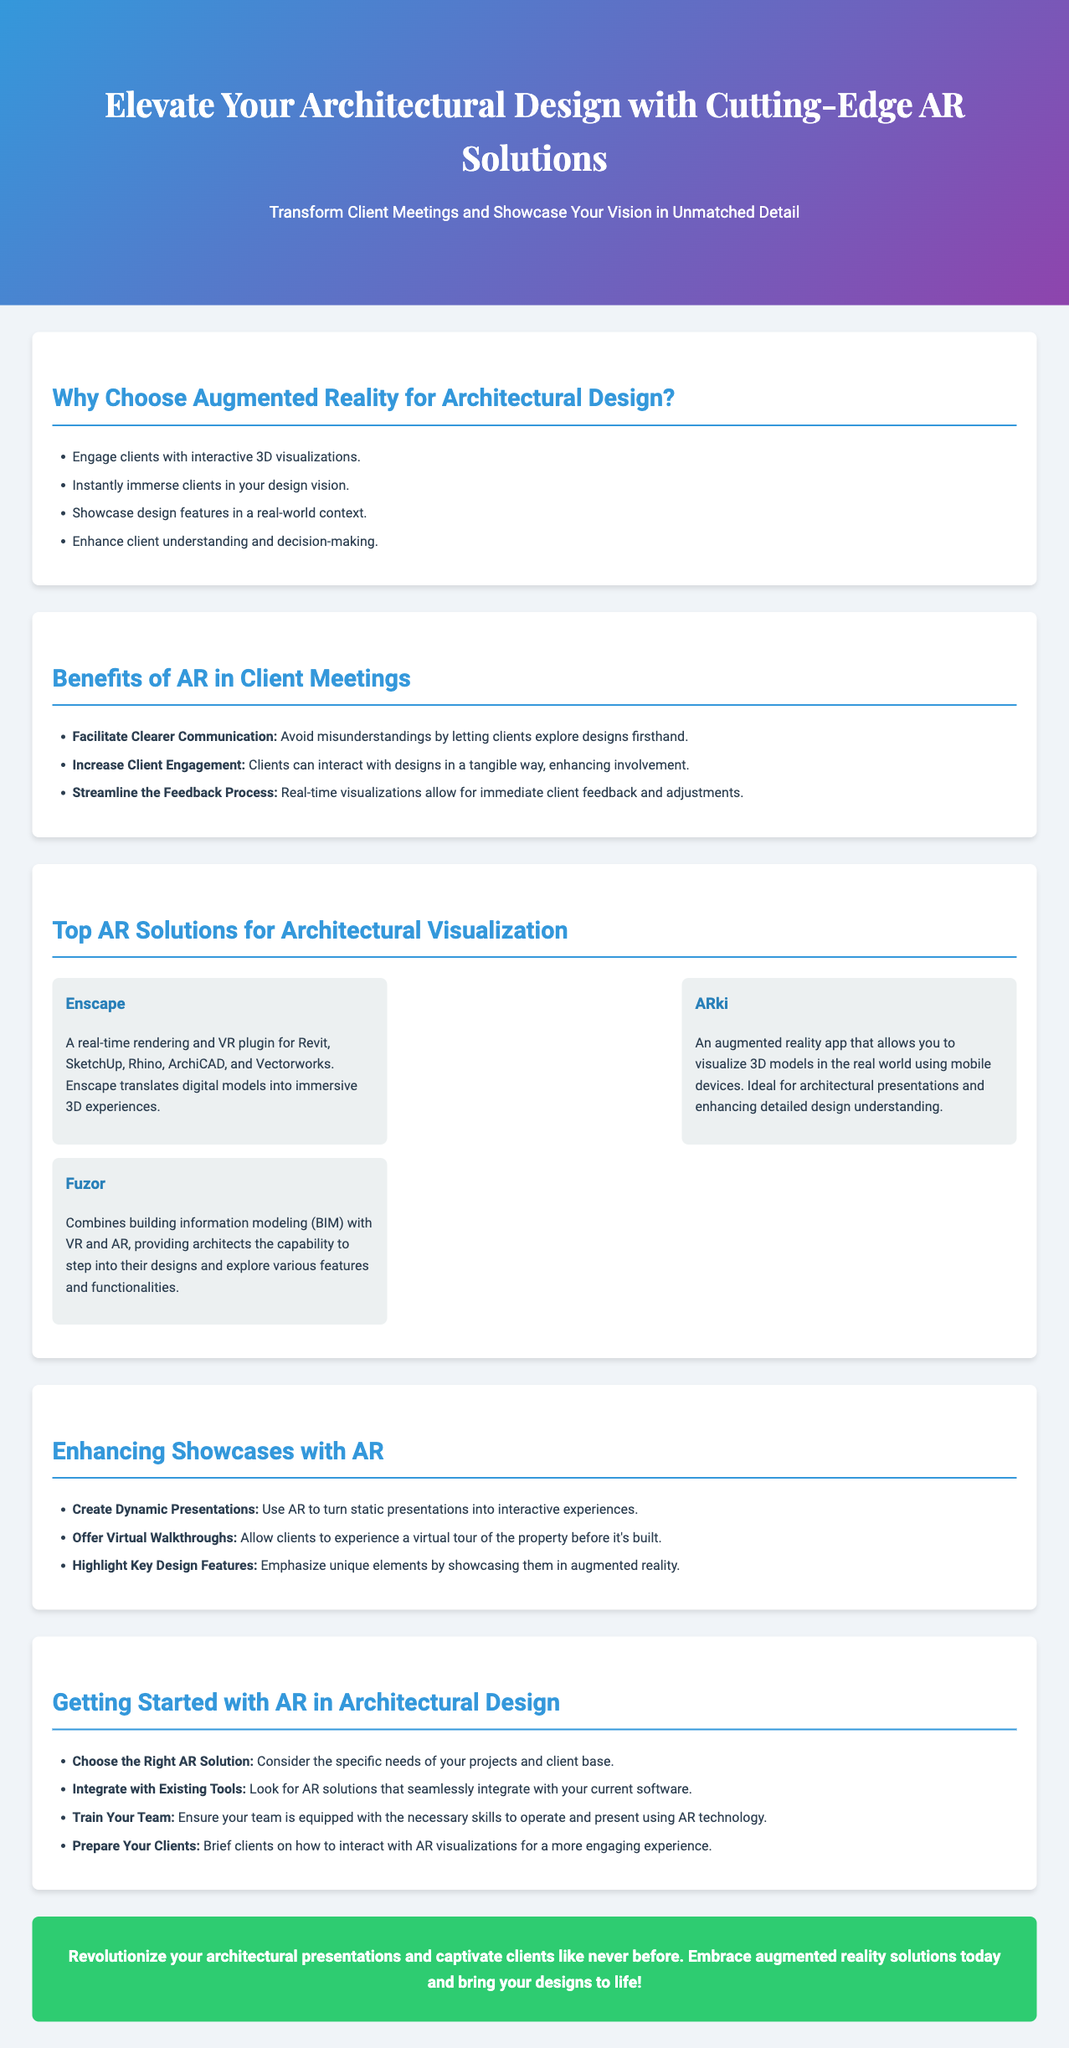What is the title of the advertisement? The title is prominently displayed at the top of the advertisement as a headline.
Answer: Elevate Your Architectural Design with Cutting-Edge AR Solutions What technology is highlighted for architectural design? The document specifically focuses on augmented reality solutions.
Answer: Augmented Reality Name one AR solution mentioned in the document. The advertisement lists several AR solutions, detailing their features.
Answer: Enscape What type of client experience does AR provide? AR aims to enhance the client experience by making designs interactive and immersive.
Answer: Interactive 3D visualizations What is one benefit of AR in client meetings? The document summarizes several key benefits of using AR in meetings with clients.
Answer: Facilitate Clearer Communication What is suggested as a first step to integrate AR? The document outlines steps to effectively start using AR in architectural projects.
Answer: Choose the Right AR Solution How can AR enhance client presentations? The advertisement describes how AR transforms traditional presentations.
Answer: Create Dynamic Presentations What should you ensure for your team when implementing AR? The document emphasizes the importance of team readiness in using new technologies.
Answer: Train Your Team 